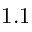<formula> <loc_0><loc_0><loc_500><loc_500>1 . 1</formula> 